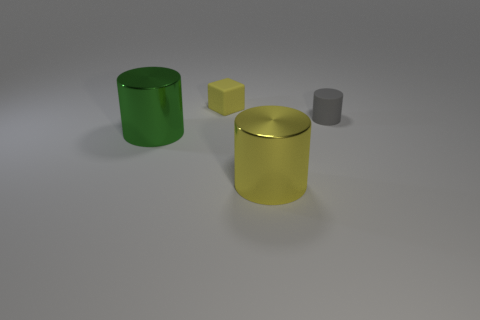Is there any other thing that is the same color as the tiny rubber cylinder?
Keep it short and to the point. No. What is the color of the metal thing behind the big metallic cylinder that is in front of the green object?
Ensure brevity in your answer.  Green. Are any green metallic objects visible?
Offer a terse response. Yes. What is the color of the cylinder that is behind the yellow metal cylinder and to the right of the small yellow rubber object?
Give a very brief answer. Gray. Is the size of the green thing in front of the gray object the same as the shiny thing that is right of the tiny cube?
Offer a terse response. Yes. How many other objects are there of the same size as the gray rubber object?
Your answer should be very brief. 1. There is a tiny matte thing that is in front of the yellow rubber block; what number of small gray matte cylinders are right of it?
Provide a succinct answer. 0. Is the number of tiny objects that are to the left of the small yellow cube less than the number of big yellow shiny cubes?
Provide a short and direct response. No. The matte object on the left side of the large metal object that is right of the shiny object that is on the left side of the big yellow shiny thing is what shape?
Offer a very short reply. Cube. Is the shape of the green object the same as the gray thing?
Provide a succinct answer. Yes. 